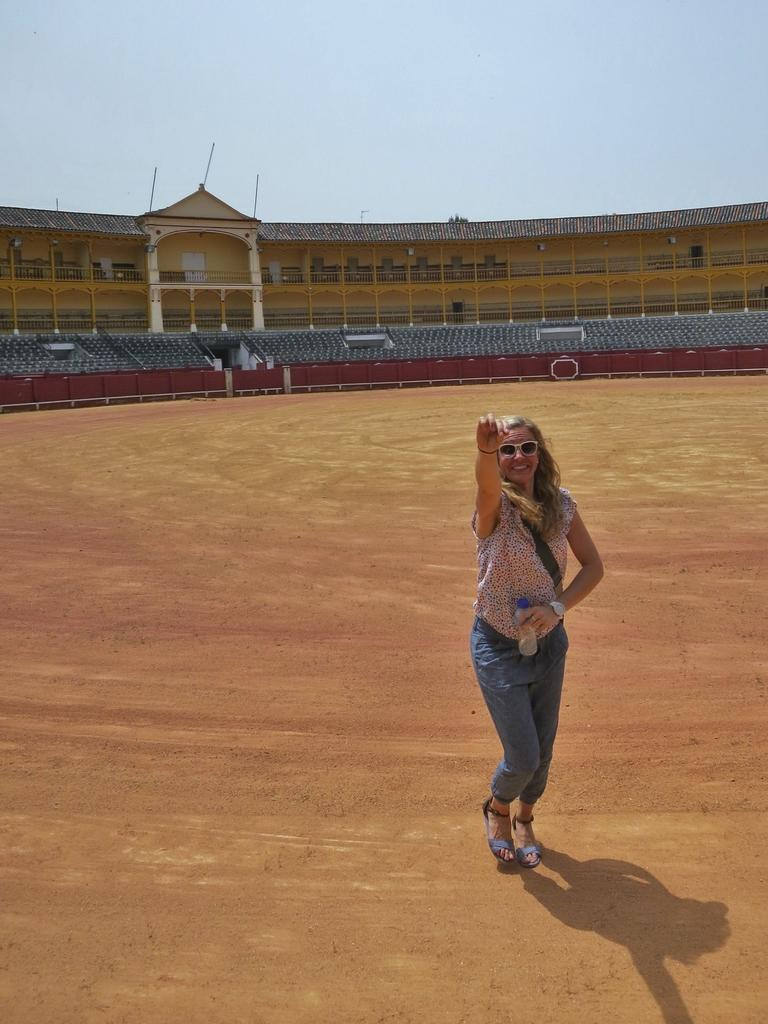Who is present in the image? There is a woman standing in the image. Where is the woman located? The woman is in a stadium. What type of seating is available in the stadium? There are chairs in the image. What can be seen at the top of the image? The sky is visible at the top of the image. Is there a table in the image? No, there is no table present in the image. Can you see a bear in the image? No, there is no bear present in the image. 